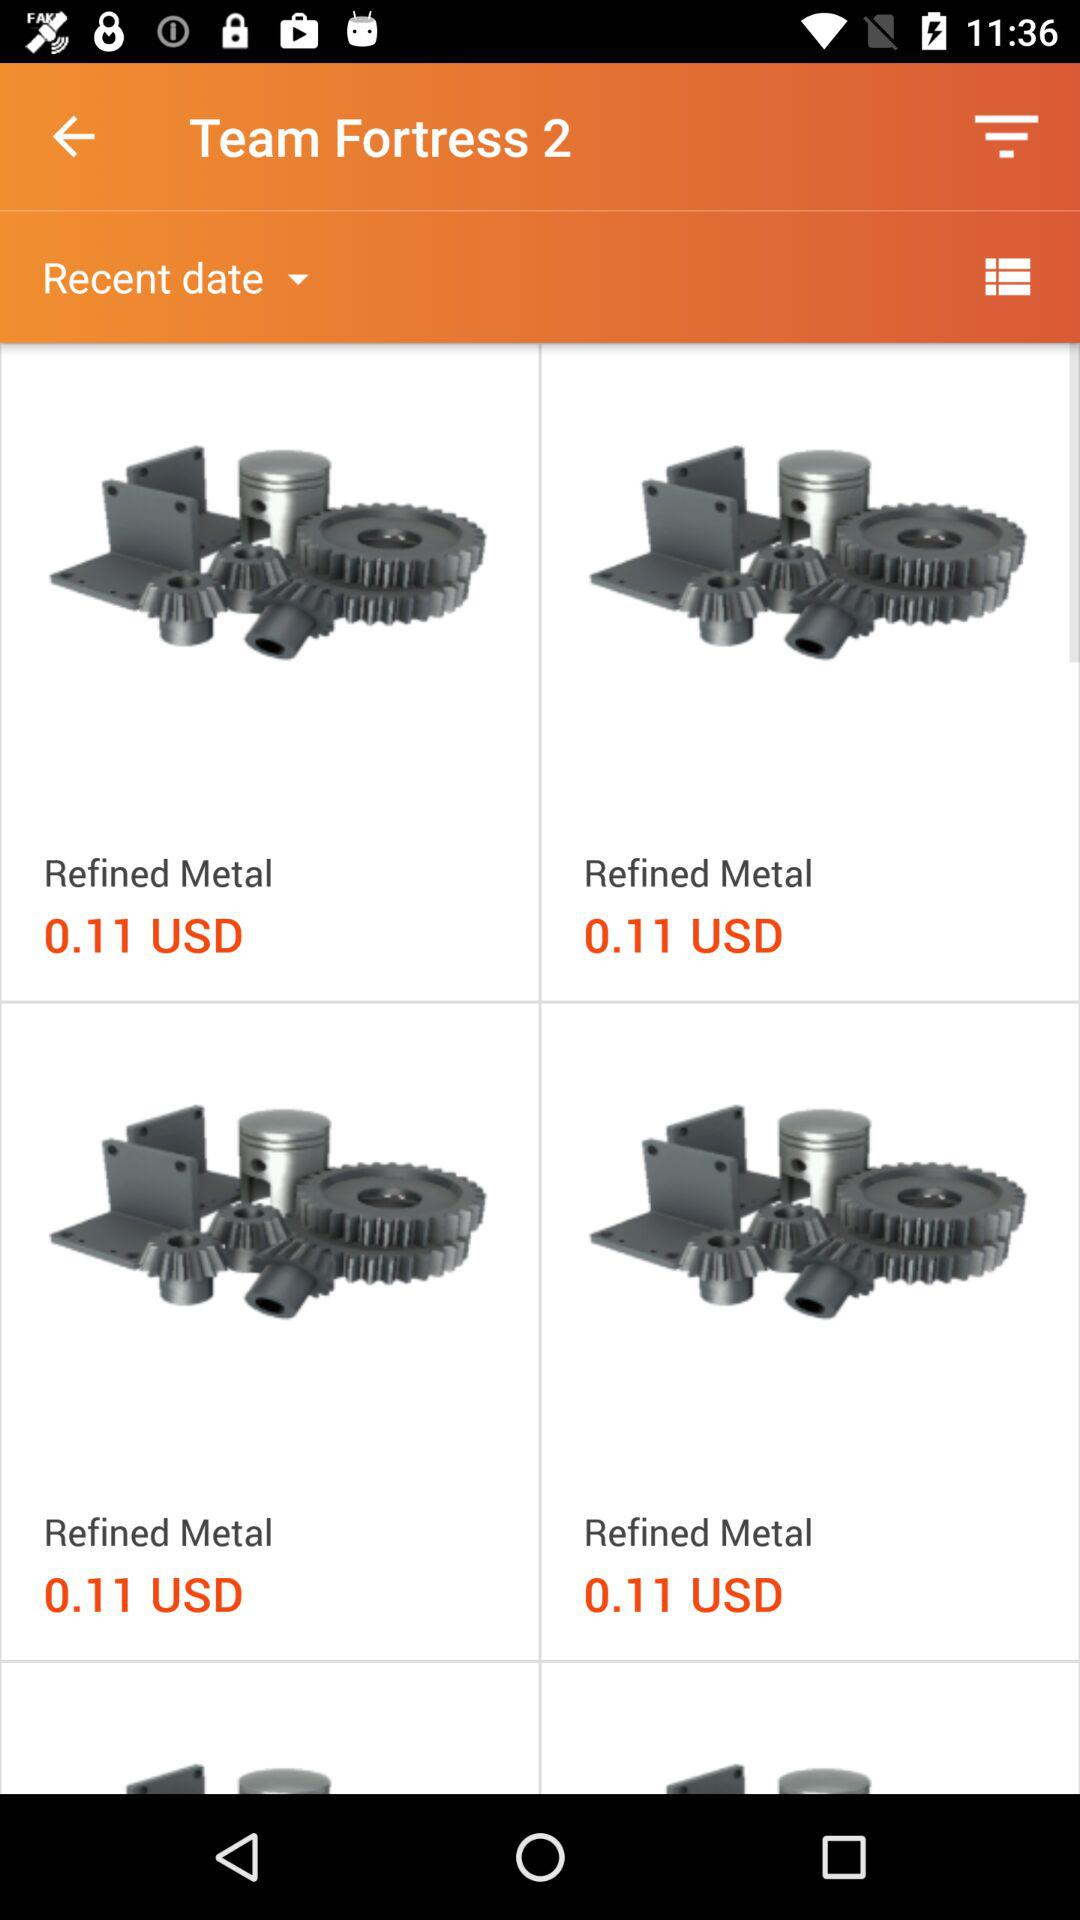What is the price of "Refined Metal"? The price of "Refined Metal" is 0.11 USD. 